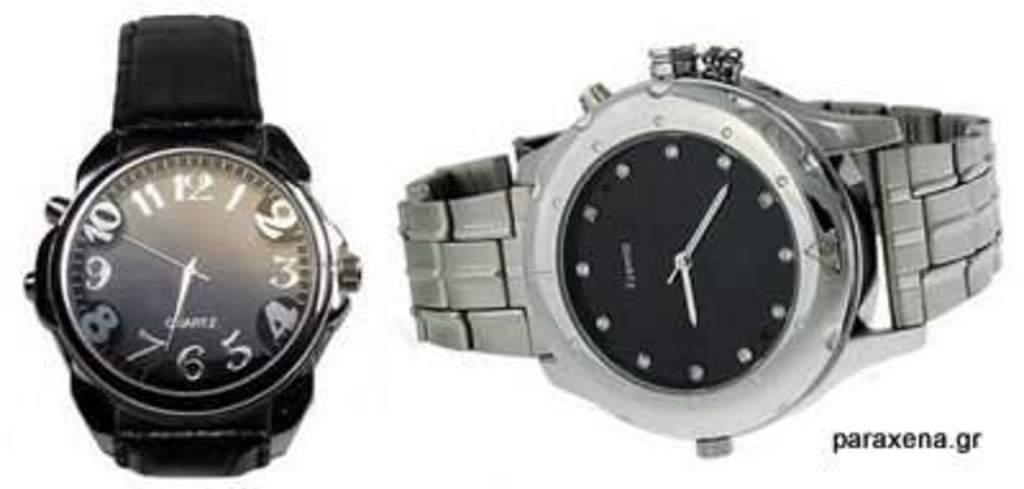In the left watch, what is the second hand on?
Your response must be concise. 10. What time is it on the left watch?
Ensure brevity in your answer.  6:50. 